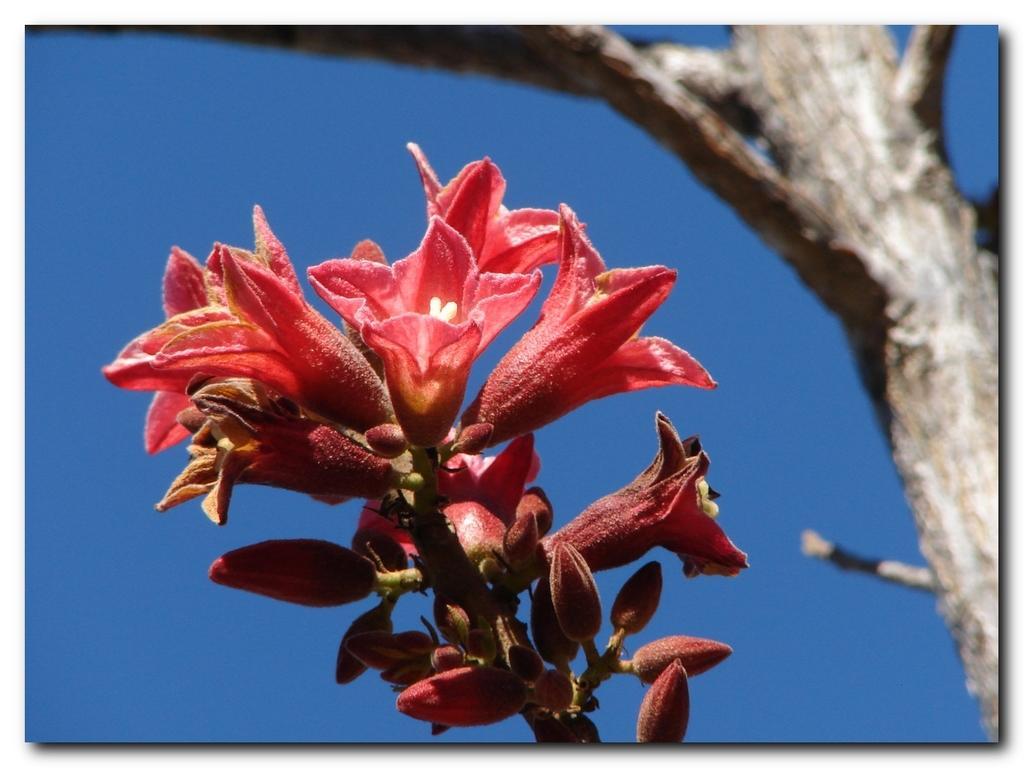Describe this image in one or two sentences. In this image I can see few red color flowers and buds. I can see the trunk and the blue color background. 